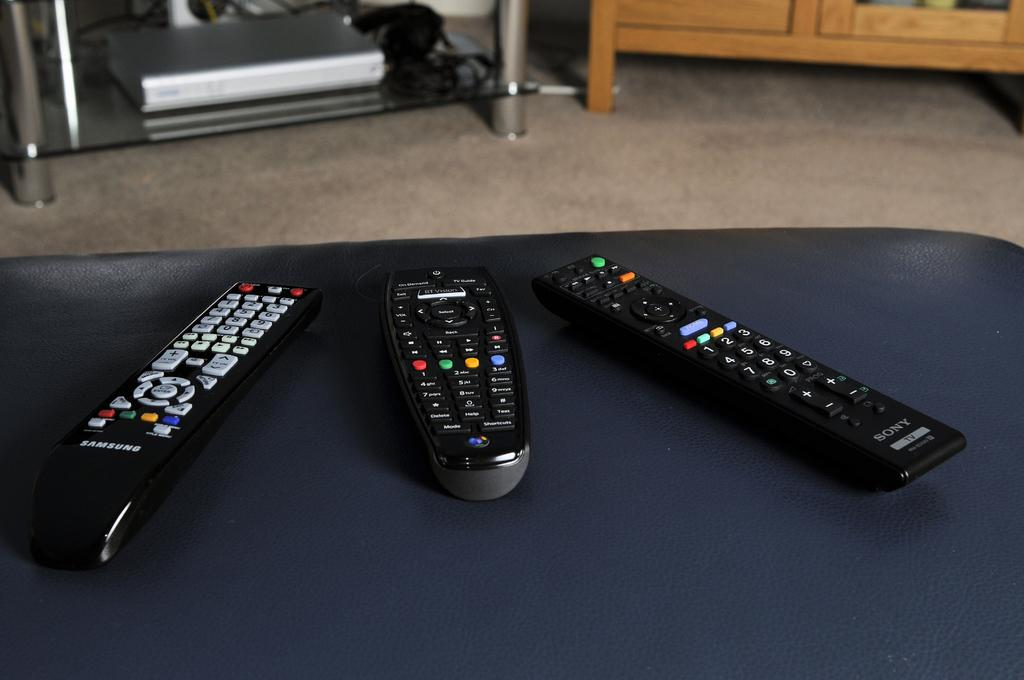<image>
Present a compact description of the photo's key features. Three remote controls, one is Samsung, another is Sony. 